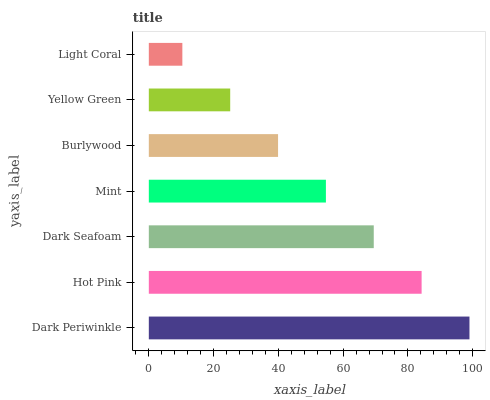Is Light Coral the minimum?
Answer yes or no. Yes. Is Dark Periwinkle the maximum?
Answer yes or no. Yes. Is Hot Pink the minimum?
Answer yes or no. No. Is Hot Pink the maximum?
Answer yes or no. No. Is Dark Periwinkle greater than Hot Pink?
Answer yes or no. Yes. Is Hot Pink less than Dark Periwinkle?
Answer yes or no. Yes. Is Hot Pink greater than Dark Periwinkle?
Answer yes or no. No. Is Dark Periwinkle less than Hot Pink?
Answer yes or no. No. Is Mint the high median?
Answer yes or no. Yes. Is Mint the low median?
Answer yes or no. Yes. Is Light Coral the high median?
Answer yes or no. No. Is Hot Pink the low median?
Answer yes or no. No. 